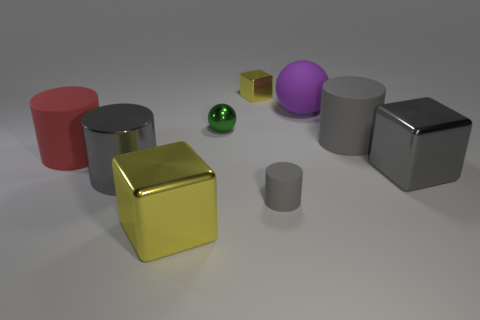There is a green object that is the same shape as the big purple matte thing; what material is it?
Keep it short and to the point. Metal. The other shiny block that is the same color as the small metallic block is what size?
Your response must be concise. Large. What number of large matte cylinders are the same color as the shiny cylinder?
Your answer should be very brief. 1. How big is the cube that is both on the left side of the tiny rubber cylinder and on the right side of the small sphere?
Your answer should be very brief. Small. There is a ball on the left side of the small cube; how big is it?
Keep it short and to the point. Small. There is a large object that is the same color as the tiny metallic block; what is its shape?
Provide a succinct answer. Cube. How many other objects are there of the same shape as the big red object?
Provide a succinct answer. 3. How many metal objects are big balls or green cubes?
Give a very brief answer. 0. What is the material of the large purple sphere that is behind the large rubber thing right of the purple rubber object?
Your answer should be very brief. Rubber. Are there more matte objects behind the red matte cylinder than blue metal objects?
Your answer should be compact. Yes. 